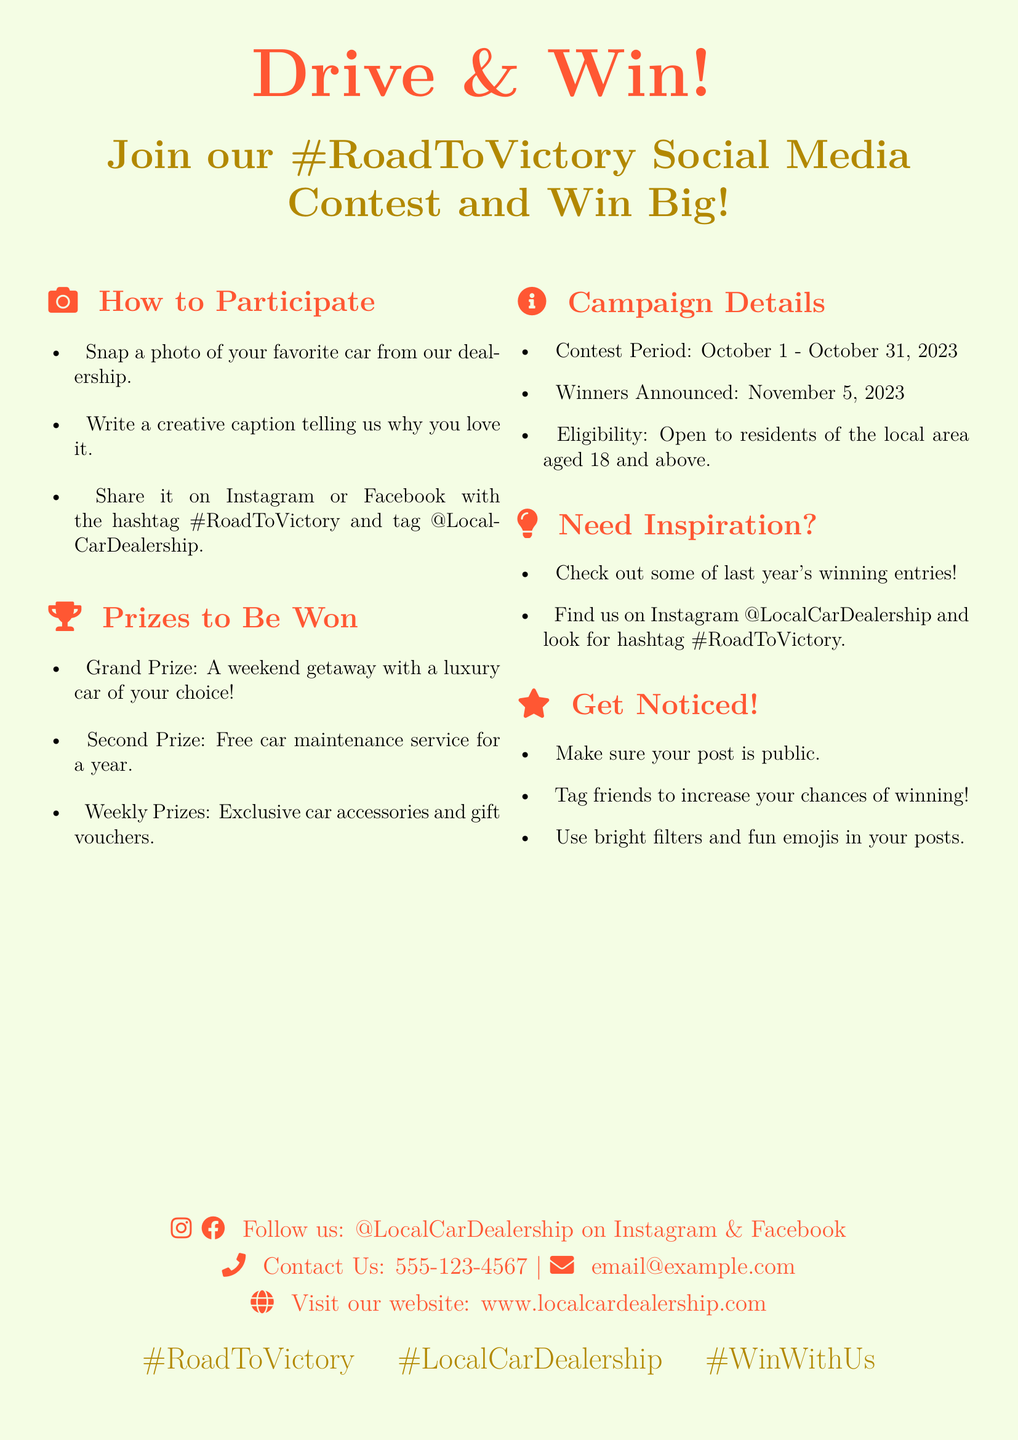What is the contest period? The contest period is specified in the document, running from October 1 to October 31, 2023.
Answer: October 1 - October 31, 2023 Who can participate in the contest? The eligibility criteria is noted in the document, stating that it is open to residents of the local area aged 18 and above.
Answer: Residents aged 18 and above What is the grand prize? The document details the prizes, indicating the grand prize as a weekend getaway with a luxury car of your choice.
Answer: A weekend getaway with a luxury car What is the hashtag for the contest? The hashtag used for the contest is highlighted in the document for participants to use in their posts.
Answer: #RoadToVictory When will the winners be announced? The date for announcing the winners is clearly stated in the campaign details within the document.
Answer: November 5, 2023 What is one way to increase chances of winning, according to the poster? The document provides tips, including tagging friends to boost visibility and engagement in the contest.
Answer: Tag friends What type of post should participants submit? The document specifies what kind of submission is needed for the contest, focusing on a photo and a caption.
Answer: A photo and a caption What can participants win on a weekly basis? The weekly prizes are mentioned among the overall prizes in the document, outlining what rewards are distributed weekly.
Answer: Exclusive car accessories and gift vouchers Where can participants follow the dealership on social media? The document indicates the social media platforms where the dealership can be followed for contest updates.
Answer: Instagram and Facebook 